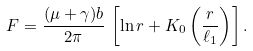Convert formula to latex. <formula><loc_0><loc_0><loc_500><loc_500>F = \frac { ( \mu + \gamma ) b } { 2 \pi } \, \left [ \ln r + K _ { 0 } \left ( \frac { r } { \ell _ { 1 } } \right ) \right ] .</formula> 